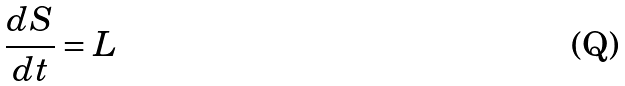<formula> <loc_0><loc_0><loc_500><loc_500>\frac { d S } { d t } = L</formula> 